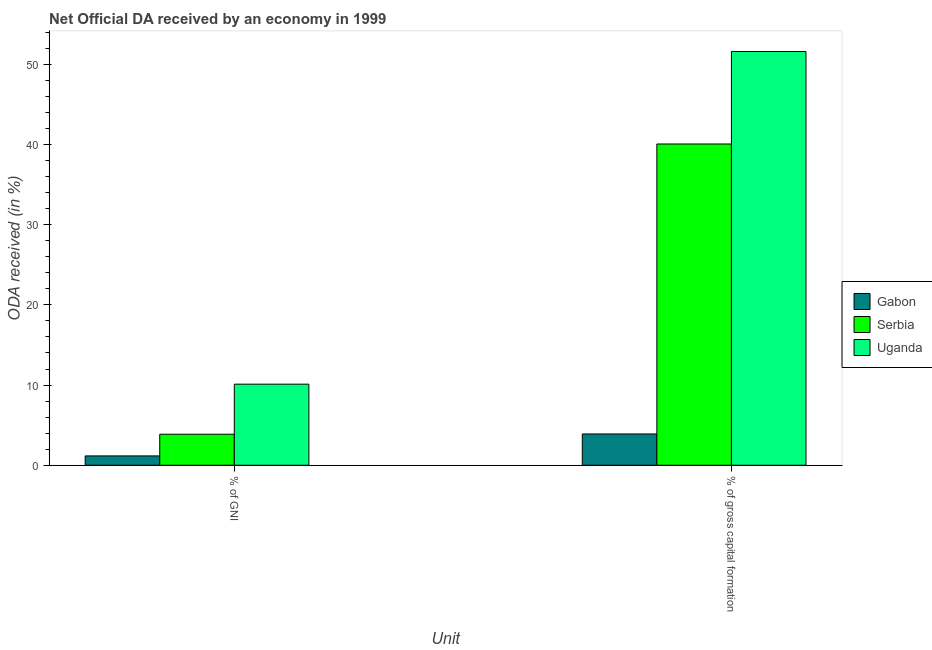Are the number of bars per tick equal to the number of legend labels?
Make the answer very short. Yes. What is the label of the 2nd group of bars from the left?
Offer a very short reply. % of gross capital formation. What is the oda received as percentage of gni in Uganda?
Offer a terse response. 10.11. Across all countries, what is the maximum oda received as percentage of gni?
Keep it short and to the point. 10.11. Across all countries, what is the minimum oda received as percentage of gross capital formation?
Give a very brief answer. 3.9. In which country was the oda received as percentage of gni maximum?
Provide a short and direct response. Uganda. In which country was the oda received as percentage of gni minimum?
Keep it short and to the point. Gabon. What is the total oda received as percentage of gross capital formation in the graph?
Your response must be concise. 95.56. What is the difference between the oda received as percentage of gni in Gabon and that in Uganda?
Keep it short and to the point. -8.95. What is the difference between the oda received as percentage of gni in Gabon and the oda received as percentage of gross capital formation in Serbia?
Your answer should be compact. -38.9. What is the average oda received as percentage of gni per country?
Offer a terse response. 5.05. What is the difference between the oda received as percentage of gni and oda received as percentage of gross capital formation in Gabon?
Keep it short and to the point. -2.74. In how many countries, is the oda received as percentage of gni greater than 30 %?
Give a very brief answer. 0. What is the ratio of the oda received as percentage of gni in Uganda to that in Gabon?
Keep it short and to the point. 8.69. Is the oda received as percentage of gross capital formation in Gabon less than that in Serbia?
Offer a terse response. Yes. In how many countries, is the oda received as percentage of gni greater than the average oda received as percentage of gni taken over all countries?
Your answer should be very brief. 1. What does the 2nd bar from the left in % of GNI represents?
Provide a short and direct response. Serbia. What does the 2nd bar from the right in % of GNI represents?
Provide a short and direct response. Serbia. How many bars are there?
Your answer should be very brief. 6. What is the difference between two consecutive major ticks on the Y-axis?
Offer a terse response. 10. Are the values on the major ticks of Y-axis written in scientific E-notation?
Your answer should be compact. No. Where does the legend appear in the graph?
Your answer should be compact. Center right. How are the legend labels stacked?
Ensure brevity in your answer.  Vertical. What is the title of the graph?
Your response must be concise. Net Official DA received by an economy in 1999. What is the label or title of the X-axis?
Make the answer very short. Unit. What is the label or title of the Y-axis?
Offer a very short reply. ODA received (in %). What is the ODA received (in %) in Gabon in % of GNI?
Your response must be concise. 1.16. What is the ODA received (in %) in Serbia in % of GNI?
Give a very brief answer. 3.87. What is the ODA received (in %) in Uganda in % of GNI?
Your answer should be very brief. 10.11. What is the ODA received (in %) of Gabon in % of gross capital formation?
Make the answer very short. 3.9. What is the ODA received (in %) in Serbia in % of gross capital formation?
Your answer should be compact. 40.06. What is the ODA received (in %) in Uganda in % of gross capital formation?
Your response must be concise. 51.59. Across all Unit, what is the maximum ODA received (in %) of Gabon?
Give a very brief answer. 3.9. Across all Unit, what is the maximum ODA received (in %) of Serbia?
Keep it short and to the point. 40.06. Across all Unit, what is the maximum ODA received (in %) of Uganda?
Keep it short and to the point. 51.59. Across all Unit, what is the minimum ODA received (in %) in Gabon?
Your response must be concise. 1.16. Across all Unit, what is the minimum ODA received (in %) of Serbia?
Your response must be concise. 3.87. Across all Unit, what is the minimum ODA received (in %) of Uganda?
Give a very brief answer. 10.11. What is the total ODA received (in %) of Gabon in the graph?
Provide a succinct answer. 5.06. What is the total ODA received (in %) in Serbia in the graph?
Your answer should be compact. 43.93. What is the total ODA received (in %) of Uganda in the graph?
Offer a terse response. 61.7. What is the difference between the ODA received (in %) in Gabon in % of GNI and that in % of gross capital formation?
Your answer should be compact. -2.74. What is the difference between the ODA received (in %) of Serbia in % of GNI and that in % of gross capital formation?
Your response must be concise. -36.2. What is the difference between the ODA received (in %) of Uganda in % of GNI and that in % of gross capital formation?
Make the answer very short. -41.48. What is the difference between the ODA received (in %) in Gabon in % of GNI and the ODA received (in %) in Serbia in % of gross capital formation?
Offer a terse response. -38.9. What is the difference between the ODA received (in %) in Gabon in % of GNI and the ODA received (in %) in Uganda in % of gross capital formation?
Give a very brief answer. -50.43. What is the difference between the ODA received (in %) of Serbia in % of GNI and the ODA received (in %) of Uganda in % of gross capital formation?
Keep it short and to the point. -47.73. What is the average ODA received (in %) of Gabon per Unit?
Provide a short and direct response. 2.53. What is the average ODA received (in %) of Serbia per Unit?
Give a very brief answer. 21.96. What is the average ODA received (in %) of Uganda per Unit?
Your answer should be very brief. 30.85. What is the difference between the ODA received (in %) of Gabon and ODA received (in %) of Serbia in % of GNI?
Keep it short and to the point. -2.7. What is the difference between the ODA received (in %) of Gabon and ODA received (in %) of Uganda in % of GNI?
Give a very brief answer. -8.95. What is the difference between the ODA received (in %) of Serbia and ODA received (in %) of Uganda in % of GNI?
Provide a short and direct response. -6.24. What is the difference between the ODA received (in %) in Gabon and ODA received (in %) in Serbia in % of gross capital formation?
Make the answer very short. -36.16. What is the difference between the ODA received (in %) of Gabon and ODA received (in %) of Uganda in % of gross capital formation?
Your answer should be very brief. -47.69. What is the difference between the ODA received (in %) in Serbia and ODA received (in %) in Uganda in % of gross capital formation?
Your answer should be very brief. -11.53. What is the ratio of the ODA received (in %) in Gabon in % of GNI to that in % of gross capital formation?
Provide a short and direct response. 0.3. What is the ratio of the ODA received (in %) of Serbia in % of GNI to that in % of gross capital formation?
Your answer should be very brief. 0.1. What is the ratio of the ODA received (in %) of Uganda in % of GNI to that in % of gross capital formation?
Offer a very short reply. 0.2. What is the difference between the highest and the second highest ODA received (in %) of Gabon?
Give a very brief answer. 2.74. What is the difference between the highest and the second highest ODA received (in %) of Serbia?
Your response must be concise. 36.2. What is the difference between the highest and the second highest ODA received (in %) in Uganda?
Offer a terse response. 41.48. What is the difference between the highest and the lowest ODA received (in %) of Gabon?
Keep it short and to the point. 2.74. What is the difference between the highest and the lowest ODA received (in %) of Serbia?
Offer a very short reply. 36.2. What is the difference between the highest and the lowest ODA received (in %) of Uganda?
Your answer should be compact. 41.48. 